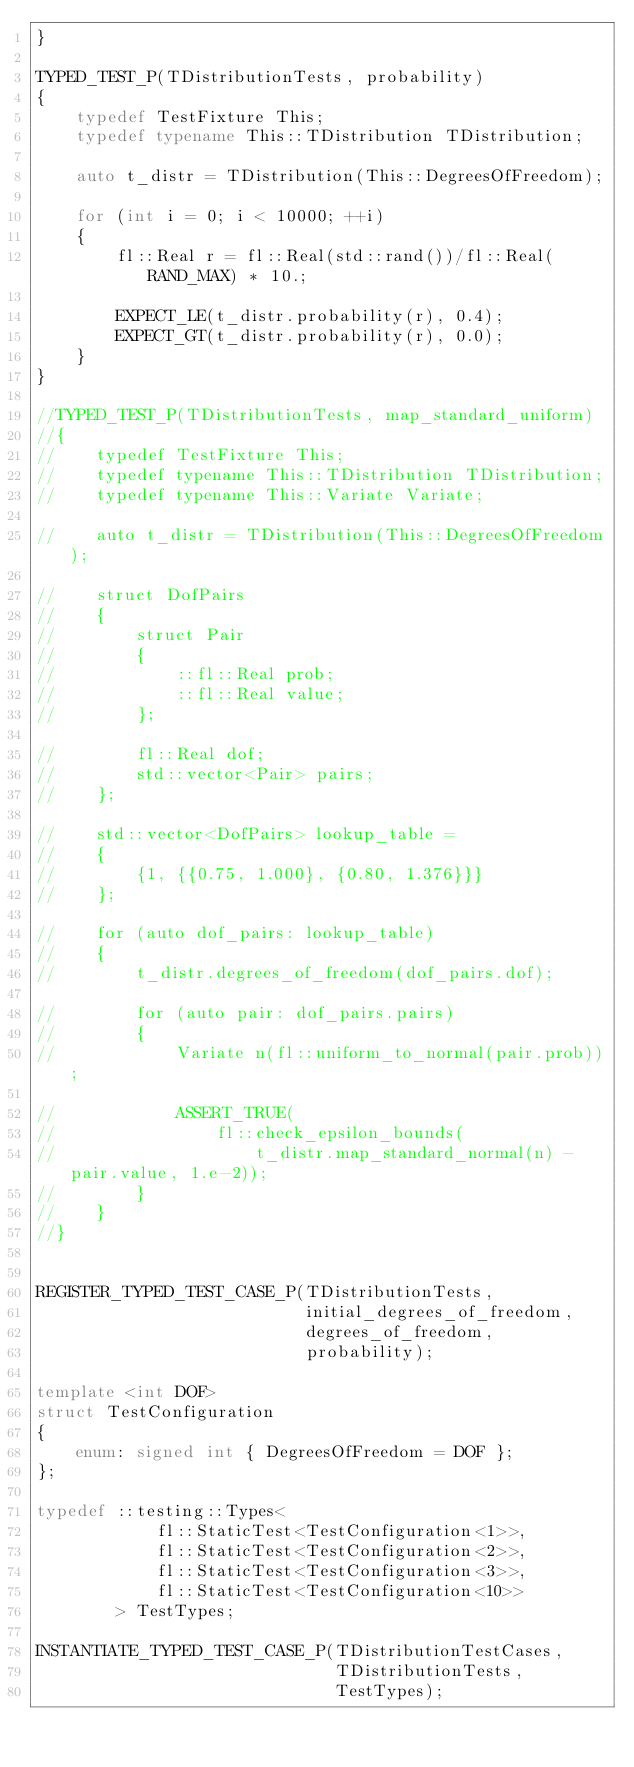<code> <loc_0><loc_0><loc_500><loc_500><_C++_>}

TYPED_TEST_P(TDistributionTests, probability)
{
    typedef TestFixture This;
    typedef typename This::TDistribution TDistribution;

    auto t_distr = TDistribution(This::DegreesOfFreedom);

    for (int i = 0; i < 10000; ++i)
    {
        fl::Real r = fl::Real(std::rand())/fl::Real(RAND_MAX) * 10.;

        EXPECT_LE(t_distr.probability(r), 0.4);
        EXPECT_GT(t_distr.probability(r), 0.0);
    }
}

//TYPED_TEST_P(TDistributionTests, map_standard_uniform)
//{
//    typedef TestFixture This;
//    typedef typename This::TDistribution TDistribution;
//    typedef typename This::Variate Variate;

//    auto t_distr = TDistribution(This::DegreesOfFreedom);

//    struct DofPairs
//    {
//        struct Pair
//        {
//            ::fl::Real prob;
//            ::fl::Real value;
//        };

//        fl::Real dof;
//        std::vector<Pair> pairs;
//    };

//    std::vector<DofPairs> lookup_table =
//    {
//        {1, {{0.75, 1.000}, {0.80, 1.376}}}
//    };

//    for (auto dof_pairs: lookup_table)
//    {
//        t_distr.degrees_of_freedom(dof_pairs.dof);

//        for (auto pair: dof_pairs.pairs)
//        {
//            Variate n(fl::uniform_to_normal(pair.prob));

//            ASSERT_TRUE(
//                fl::check_epsilon_bounds(
//                    t_distr.map_standard_normal(n) - pair.value, 1.e-2));
//        }
//    }
//}


REGISTER_TYPED_TEST_CASE_P(TDistributionTests,
                           initial_degrees_of_freedom,
                           degrees_of_freedom,
                           probability);

template <int DOF>
struct TestConfiguration
{
    enum: signed int { DegreesOfFreedom = DOF };
};

typedef ::testing::Types<
            fl::StaticTest<TestConfiguration<1>>,
            fl::StaticTest<TestConfiguration<2>>,
            fl::StaticTest<TestConfiguration<3>>,
            fl::StaticTest<TestConfiguration<10>>
        > TestTypes;

INSTANTIATE_TYPED_TEST_CASE_P(TDistributionTestCases,
                              TDistributionTests,
                              TestTypes);
</code> 